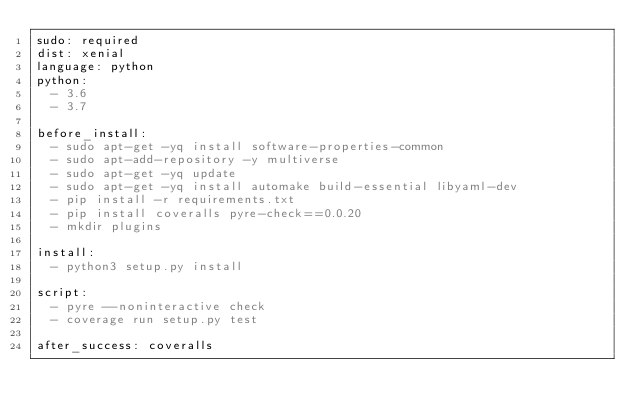<code> <loc_0><loc_0><loc_500><loc_500><_YAML_>sudo: required
dist: xenial
language: python
python:
  - 3.6
  - 3.7

before_install:
  - sudo apt-get -yq install software-properties-common
  - sudo apt-add-repository -y multiverse
  - sudo apt-get -yq update
  - sudo apt-get -yq install automake build-essential libyaml-dev
  - pip install -r requirements.txt
  - pip install coveralls pyre-check==0.0.20
  - mkdir plugins

install:
  - python3 setup.py install

script:
  - pyre --noninteractive check
  - coverage run setup.py test

after_success: coveralls
</code> 